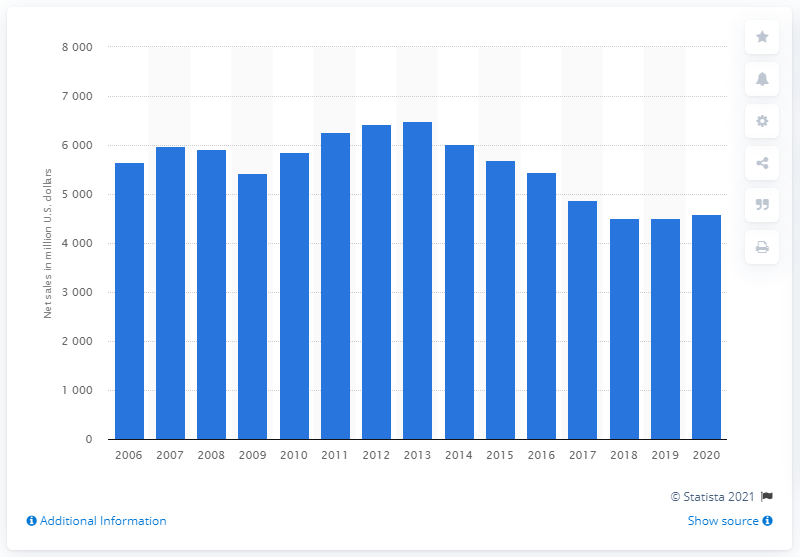Point out several critical features in this image. Mattel achieved its highest revenue in 2013 with a total of 64,84.89. Mattel's global net sales in 2020 were 4583.7 million dollars. 